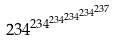<formula> <loc_0><loc_0><loc_500><loc_500>2 3 4 ^ { 2 3 4 ^ { 2 3 4 ^ { 2 3 4 ^ { 2 3 4 ^ { 2 3 7 } } } } }</formula> 